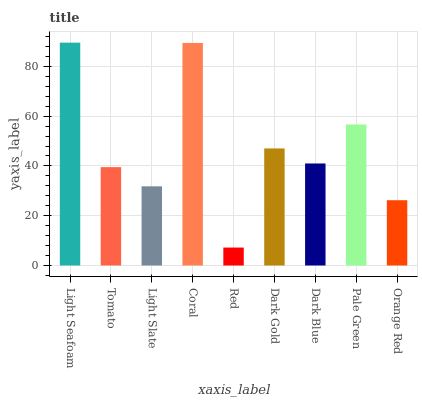Is Red the minimum?
Answer yes or no. Yes. Is Light Seafoam the maximum?
Answer yes or no. Yes. Is Tomato the minimum?
Answer yes or no. No. Is Tomato the maximum?
Answer yes or no. No. Is Light Seafoam greater than Tomato?
Answer yes or no. Yes. Is Tomato less than Light Seafoam?
Answer yes or no. Yes. Is Tomato greater than Light Seafoam?
Answer yes or no. No. Is Light Seafoam less than Tomato?
Answer yes or no. No. Is Dark Blue the high median?
Answer yes or no. Yes. Is Dark Blue the low median?
Answer yes or no. Yes. Is Tomato the high median?
Answer yes or no. No. Is Orange Red the low median?
Answer yes or no. No. 